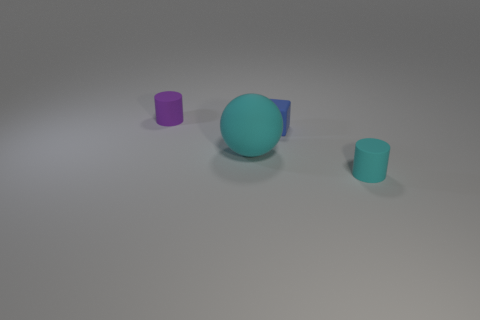Are the tiny cylinder that is right of the small purple matte thing and the blue cube made of the same material? Although the blue cube and the small purple cylinder exhibit similar shades of matte finish, without additional context, we cannot definitively determine if they are made of the exact same material. However, based on the image alone, they appear to have a comparable surface texture that suggests they might be. 